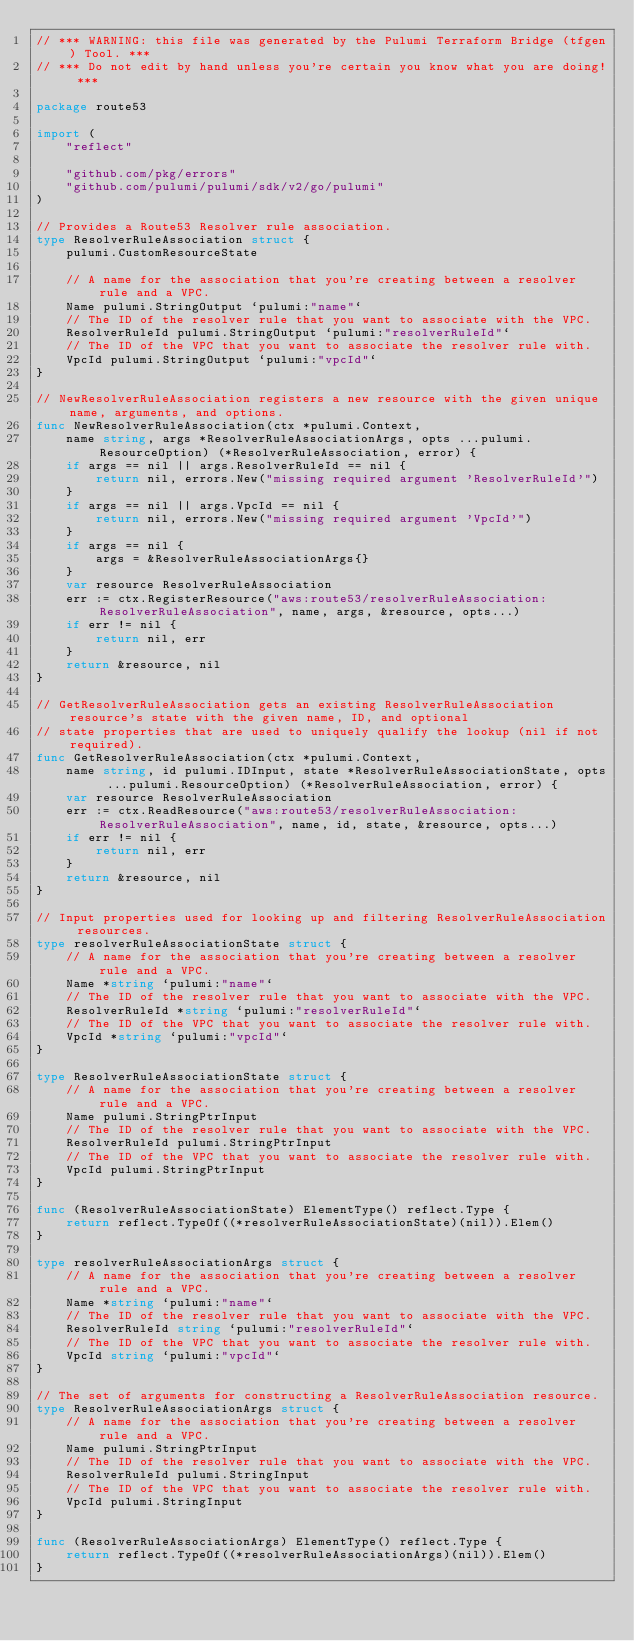<code> <loc_0><loc_0><loc_500><loc_500><_Go_>// *** WARNING: this file was generated by the Pulumi Terraform Bridge (tfgen) Tool. ***
// *** Do not edit by hand unless you're certain you know what you are doing! ***

package route53

import (
	"reflect"

	"github.com/pkg/errors"
	"github.com/pulumi/pulumi/sdk/v2/go/pulumi"
)

// Provides a Route53 Resolver rule association.
type ResolverRuleAssociation struct {
	pulumi.CustomResourceState

	// A name for the association that you're creating between a resolver rule and a VPC.
	Name pulumi.StringOutput `pulumi:"name"`
	// The ID of the resolver rule that you want to associate with the VPC.
	ResolverRuleId pulumi.StringOutput `pulumi:"resolverRuleId"`
	// The ID of the VPC that you want to associate the resolver rule with.
	VpcId pulumi.StringOutput `pulumi:"vpcId"`
}

// NewResolverRuleAssociation registers a new resource with the given unique name, arguments, and options.
func NewResolverRuleAssociation(ctx *pulumi.Context,
	name string, args *ResolverRuleAssociationArgs, opts ...pulumi.ResourceOption) (*ResolverRuleAssociation, error) {
	if args == nil || args.ResolverRuleId == nil {
		return nil, errors.New("missing required argument 'ResolverRuleId'")
	}
	if args == nil || args.VpcId == nil {
		return nil, errors.New("missing required argument 'VpcId'")
	}
	if args == nil {
		args = &ResolverRuleAssociationArgs{}
	}
	var resource ResolverRuleAssociation
	err := ctx.RegisterResource("aws:route53/resolverRuleAssociation:ResolverRuleAssociation", name, args, &resource, opts...)
	if err != nil {
		return nil, err
	}
	return &resource, nil
}

// GetResolverRuleAssociation gets an existing ResolverRuleAssociation resource's state with the given name, ID, and optional
// state properties that are used to uniquely qualify the lookup (nil if not required).
func GetResolverRuleAssociation(ctx *pulumi.Context,
	name string, id pulumi.IDInput, state *ResolverRuleAssociationState, opts ...pulumi.ResourceOption) (*ResolverRuleAssociation, error) {
	var resource ResolverRuleAssociation
	err := ctx.ReadResource("aws:route53/resolverRuleAssociation:ResolverRuleAssociation", name, id, state, &resource, opts...)
	if err != nil {
		return nil, err
	}
	return &resource, nil
}

// Input properties used for looking up and filtering ResolverRuleAssociation resources.
type resolverRuleAssociationState struct {
	// A name for the association that you're creating between a resolver rule and a VPC.
	Name *string `pulumi:"name"`
	// The ID of the resolver rule that you want to associate with the VPC.
	ResolverRuleId *string `pulumi:"resolverRuleId"`
	// The ID of the VPC that you want to associate the resolver rule with.
	VpcId *string `pulumi:"vpcId"`
}

type ResolverRuleAssociationState struct {
	// A name for the association that you're creating between a resolver rule and a VPC.
	Name pulumi.StringPtrInput
	// The ID of the resolver rule that you want to associate with the VPC.
	ResolverRuleId pulumi.StringPtrInput
	// The ID of the VPC that you want to associate the resolver rule with.
	VpcId pulumi.StringPtrInput
}

func (ResolverRuleAssociationState) ElementType() reflect.Type {
	return reflect.TypeOf((*resolverRuleAssociationState)(nil)).Elem()
}

type resolverRuleAssociationArgs struct {
	// A name for the association that you're creating between a resolver rule and a VPC.
	Name *string `pulumi:"name"`
	// The ID of the resolver rule that you want to associate with the VPC.
	ResolverRuleId string `pulumi:"resolverRuleId"`
	// The ID of the VPC that you want to associate the resolver rule with.
	VpcId string `pulumi:"vpcId"`
}

// The set of arguments for constructing a ResolverRuleAssociation resource.
type ResolverRuleAssociationArgs struct {
	// A name for the association that you're creating between a resolver rule and a VPC.
	Name pulumi.StringPtrInput
	// The ID of the resolver rule that you want to associate with the VPC.
	ResolverRuleId pulumi.StringInput
	// The ID of the VPC that you want to associate the resolver rule with.
	VpcId pulumi.StringInput
}

func (ResolverRuleAssociationArgs) ElementType() reflect.Type {
	return reflect.TypeOf((*resolverRuleAssociationArgs)(nil)).Elem()
}
</code> 